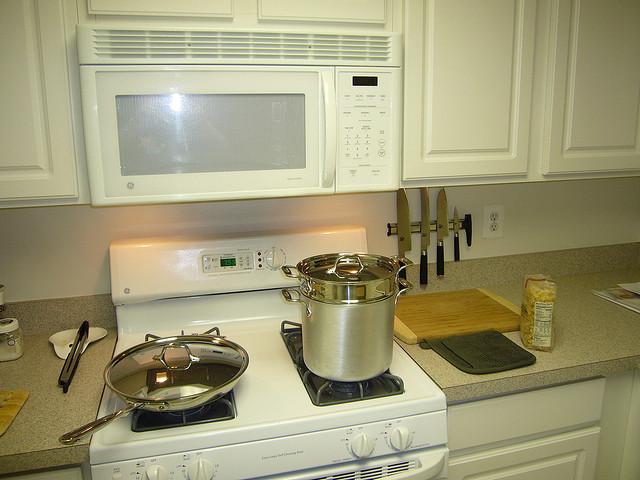Is this kitchen modern?
Keep it brief. Yes. What color is the pot holder?
Keep it brief. Green. Is this a gas stove?
Give a very brief answer. Yes. Do you see any knives?
Short answer required. Yes. 